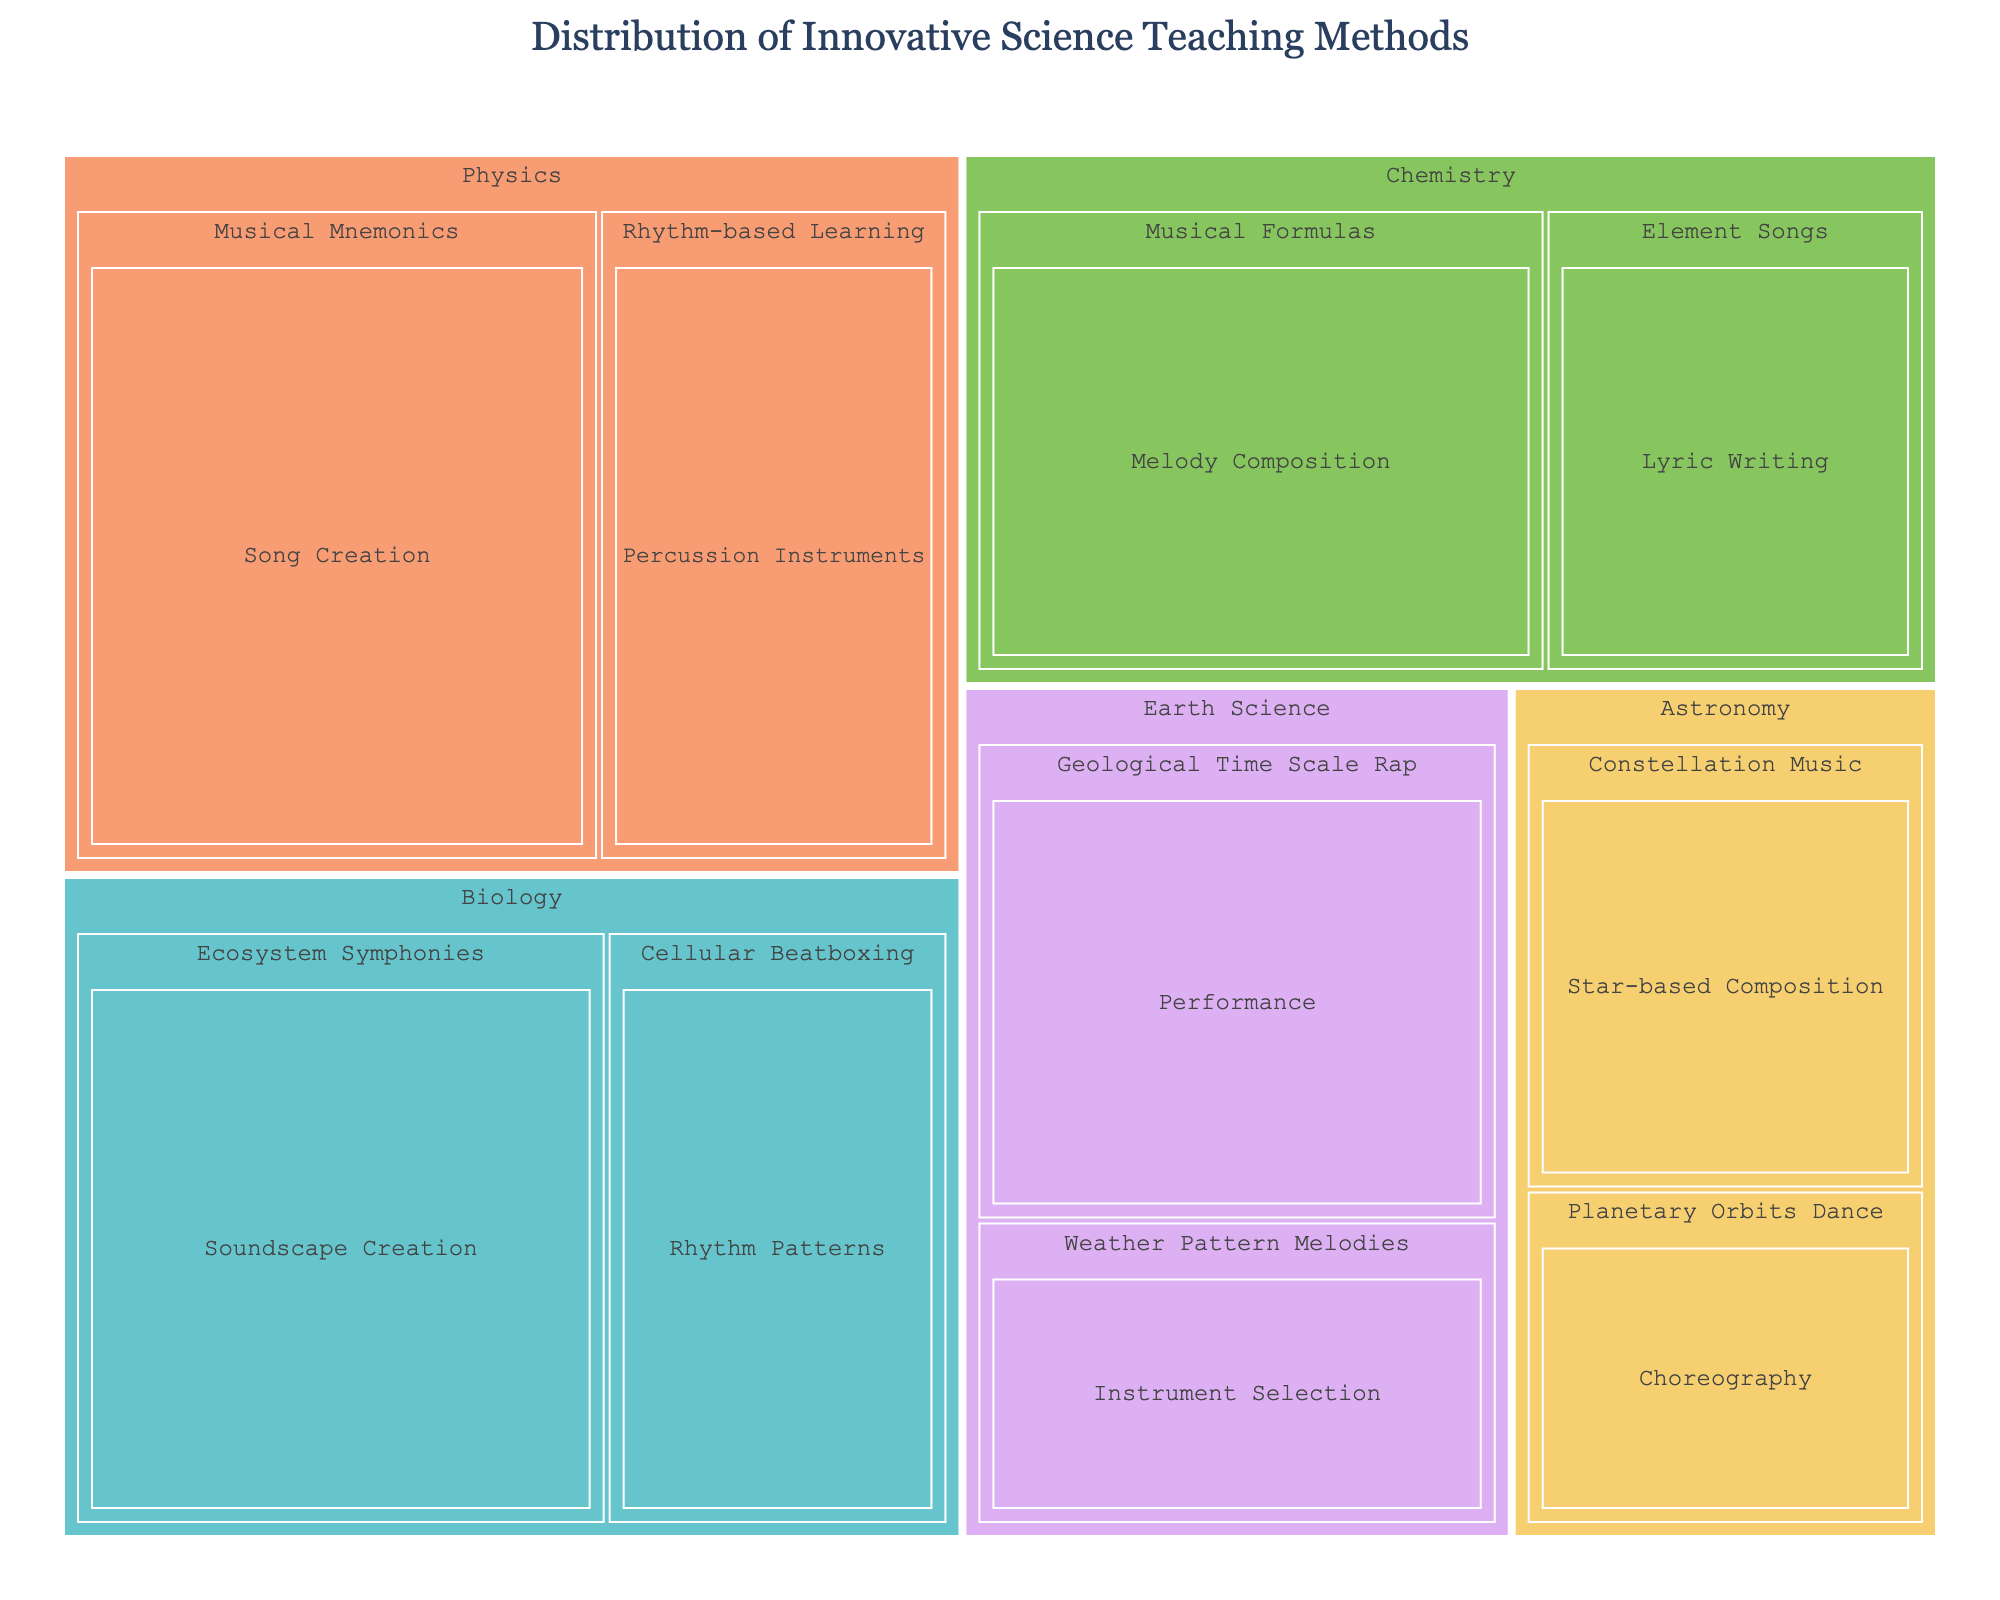What is the title of the treemap? The title is displayed at the top of the treemap, indicating what the visualization represents.
Answer: Distribution of Innovative Science Teaching Methods Which subject has the highest total percentage? Sum the percentages of the methods under each subject category and compare them. Physics: 15+10=25, Chemistry: 12+8=20, Biology: 14+9=23, Earth Science: 11+7=18, Astronomy: 6+8=14. Physics has the highest total percentage.
Answer: Physics Which innovative approach in Biology has the larger percentage? Look at the percentages of the innovative approaches under Biology and compare them. Ecosystem Symphonies: 14%, Cellular Beatboxing: 9%. Ecosystem Symphonies has a larger percentage.
Answer: Ecosystem Symphonies What is the combined percentage of the Rhythm-based Learning method and the Musical Mnemonics method in Physics? Add the percentages of Rhythm-based Learning and Musical Mnemonics in the Physics category: 10+15=25
Answer: 25% Which innovative approach has the smallest percentage in the entire treemap? Identify the method with the smallest percentage value in the dataset. Weather Pattern Melodies in Earth Science has the smallest percentage, which is 7%.
Answer: Weather Pattern Melodies How many innovative methods does Chemistry utilize? Count the number of unique methods listed under Chemistry. Musical Formulas, Element Songs. Therefore, Chemistry utilizes 2 innovative methods.
Answer: 2 Which subject employs Musically-based methods most extensively, as indicated by its total percentage? Sum the percentages of all the innovative approaches for each subject and compare. Physics: 15+10=25, Chemistry: 12+8=20, Biology: 14+9=23, Earth Science: 11+7=18, Astronomy: 6+8=14. Physics employs musically-based methods most extensively with a total percentage of 25.
Answer: Physics Which method is unique to Earth Science? Look at the methods under Earth Science and identify which methods only appear here. Geological Time Scale Rap and Weather Pattern Melodies are both unique to Earth Science but select one.
Answer: Geological Time Scale Rap What is the average percentage of innovative approaches in Astronomy? Calculate the mean of the percentages of the innovative approaches under Astronomy: (6+8)/2 = 7
Answer: 7% Compare the percentages of Planetary Orbits Dance in Astronomy to Element Songs in Chemistry. Look at the treemap and compare the two percentages. Planetary Orbits Dance: 6%, Element Songs: 8%. Element Songs is higher than Planetary Orbits Dance.
Answer: Element Songs is higher 